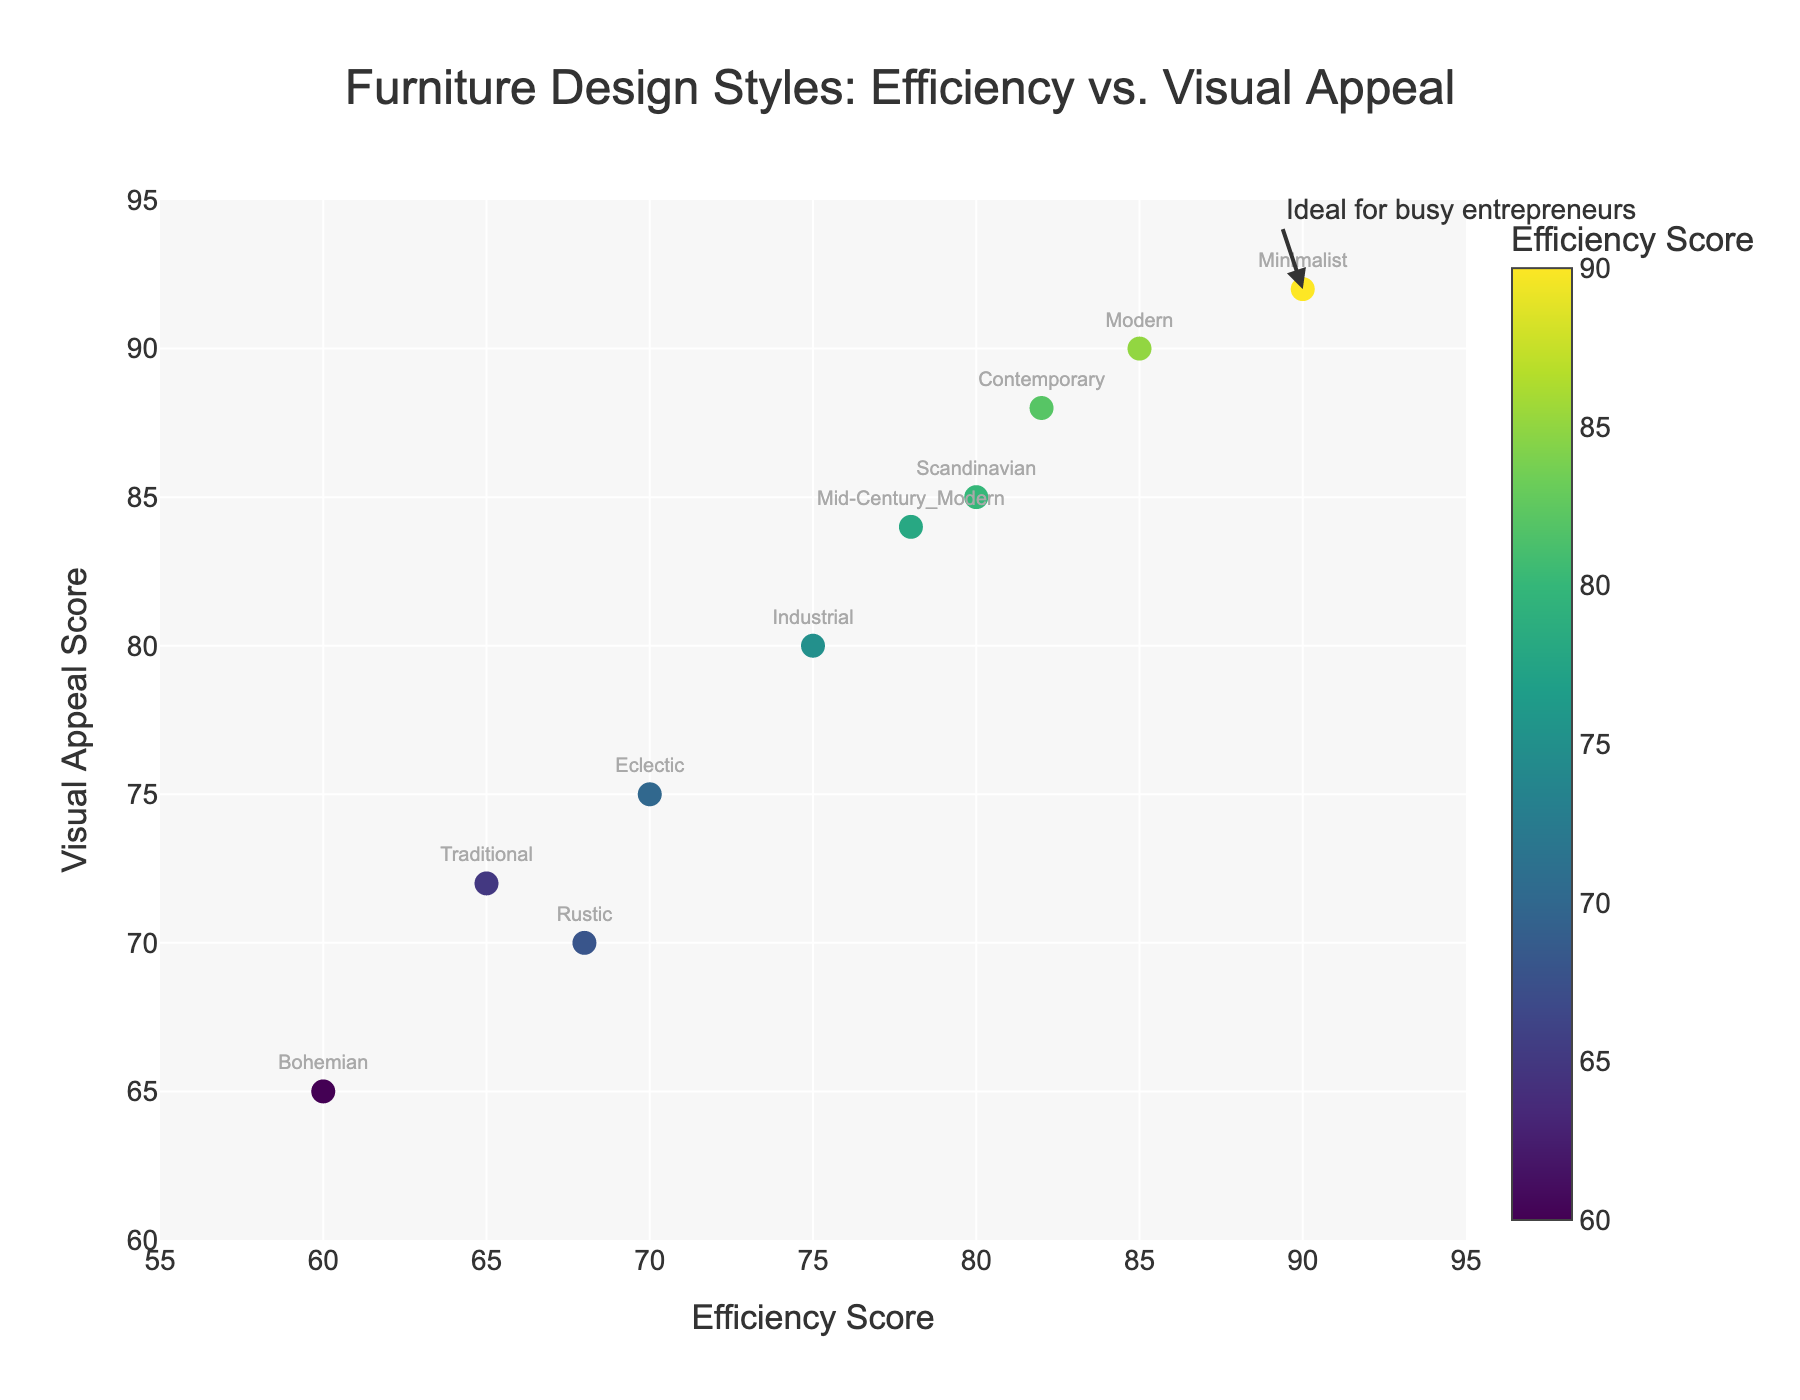What's the title of the scatter plot? The title is displayed at the top of the plot. It reads, "Furniture Design Styles: Efficiency vs. Visual Appeal".
Answer: Furniture Design Styles: Efficiency vs. Visual Appeal How many data points are there on the plot? There are 10 furniture design styles plotted, with each style represented by a unique point on the scatter plot.
Answer: 10 Which design style has the highest efficiency score? The highest efficiency score is visible in the data points plotted along the X-axis. The "Minimalist" design style has an efficiency score of 90.
Answer: Minimalist What is the visual appeal score for the "Bohemian" design style? By locating the "Bohemian" design style on the scatter plot and referencing its Y-coordinate, we find that its visual appeal score is 65.
Answer: 65 Which design style has both a high efficiency score and a high visual appeal score? Looking for data points in the upper-right quadrant of the plot for both high efficiency (X-axis) and visual appeal (Y-axis) scores, the "Minimalist" design style stands out with efficiency and visual appeal scores of 90 and 92, respectively.
Answer: Minimalist Compare the visual appeal scores of "Industrial" and "Eclectic" design styles. Which one is higher? By looking at the Y-coordinate of both design styles, "Industrial" has a visual appeal score of 80, while "Eclectic" has a score of 75. Industrial's visual appeal score is higher.
Answer: Industrial Which design style has the lowest visual appeal score? The lowest point on the Y-axis represents the design style with the lowest visual appeal score, which is "Bohemian" with a score of 65.
Answer: Bohemian Calculate the average efficiency score of "Traditional," "Rustic," and "Bohemian" design styles. Sum the efficiency scores (65 + 68 + 60 = 193) and divide by the number of design styles (3). Average = 193 / 3 = 64.33.
Answer: 64.33 What is the difference in visual appeal scores between "Modern" and "Traditional" design styles? Subtract the visual appeal score of "Traditional" (72) from that of "Modern" (90). Difference = 90 - 72 = 18.
Answer: 18 Which design style has the lowest efficiency score? By identifying the leftmost point on the X-axis, the design style with the lowest efficiency score is "Bohemian" with a score of 60.
Answer: Bohemian 